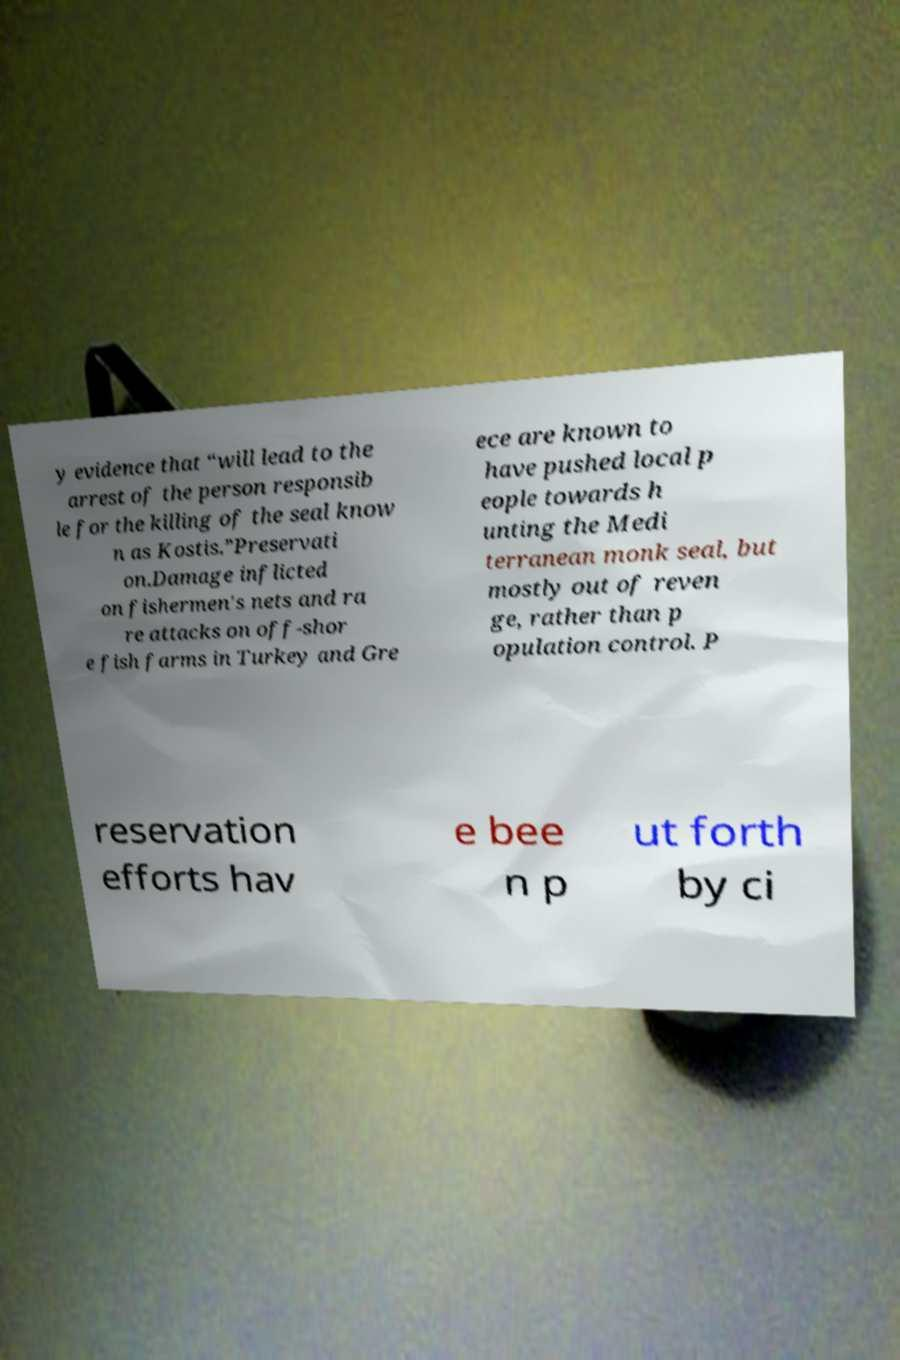Please identify and transcribe the text found in this image. y evidence that “will lead to the arrest of the person responsib le for the killing of the seal know n as Kostis.”Preservati on.Damage inflicted on fishermen's nets and ra re attacks on off-shor e fish farms in Turkey and Gre ece are known to have pushed local p eople towards h unting the Medi terranean monk seal, but mostly out of reven ge, rather than p opulation control. P reservation efforts hav e bee n p ut forth by ci 